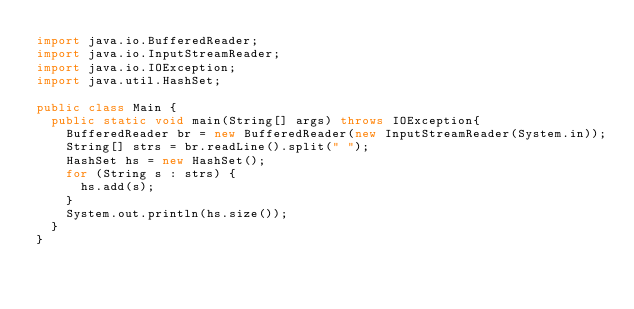Convert code to text. <code><loc_0><loc_0><loc_500><loc_500><_Java_>import java.io.BufferedReader;
import java.io.InputStreamReader;
import java.io.IOException;
import java.util.HashSet;

public class Main {
  public static void main(String[] args) throws IOException{
    BufferedReader br = new BufferedReader(new InputStreamReader(System.in));
    String[] strs = br.readLine().split(" ");
    HashSet hs = new HashSet();
    for (String s : strs) {
      hs.add(s);
    }
    System.out.println(hs.size());
  }
}</code> 